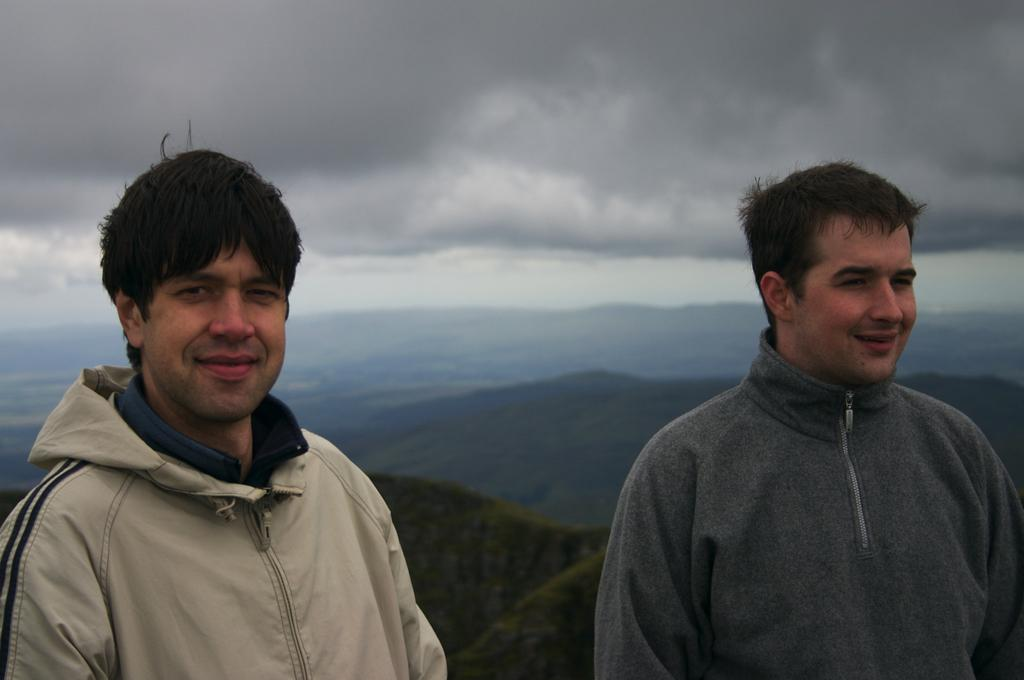How many people are in the image? There are two persons in the image. What is the facial expression of the persons in the image? The persons are smiling. What additional element is present in the image? There is a smiley face in the image. What can be seen in the background of the image? Mountains, grass, and the sky are visible in the background of the image. Where is the cactus located in the image? There is no cactus present in the image. What type of steel is used to construct the mountains in the image? The mountains in the image are natural landforms and not constructed with steel. 